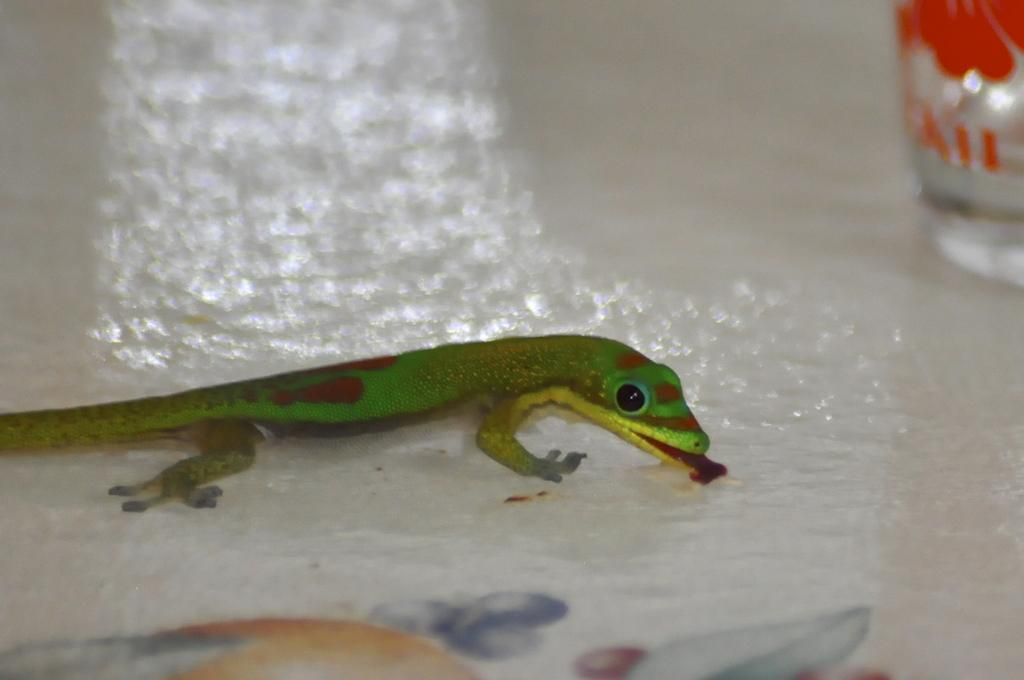What type of animal is in the image? There is a lizard in the image. What is the color of the surface the lizard is on? The lizard is on a white surface. Can you describe any other objects in the image? There might be a bottle in the image. How would you describe the background of the image? The background of the image is blurred. What type of bone can be seen in the image? There is no bone present in the image; it features a lizard on a white surface with a possible bottle and a blurred background. 